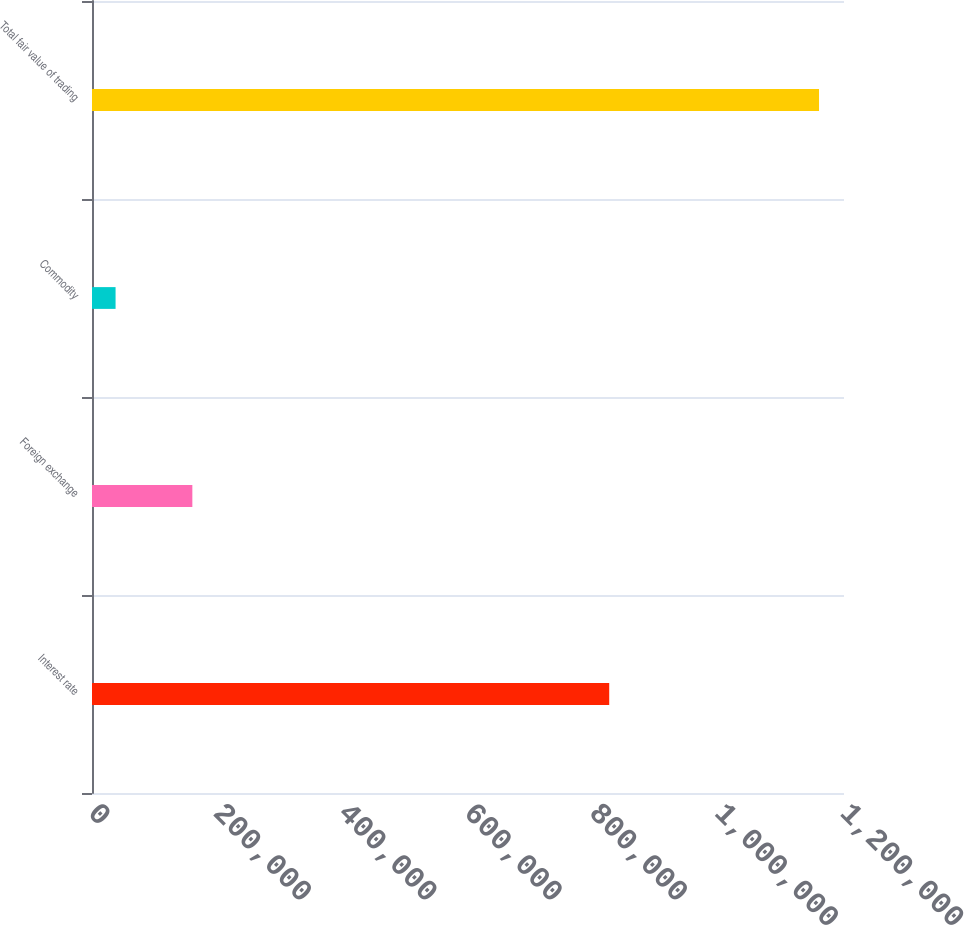Convert chart to OTSL. <chart><loc_0><loc_0><loc_500><loc_500><bar_chart><fcel>Interest rate<fcel>Foreign exchange<fcel>Commodity<fcel>Total fair value of trading<nl><fcel>825354<fcel>160125<fcel>37614<fcel>1.16015e+06<nl></chart> 